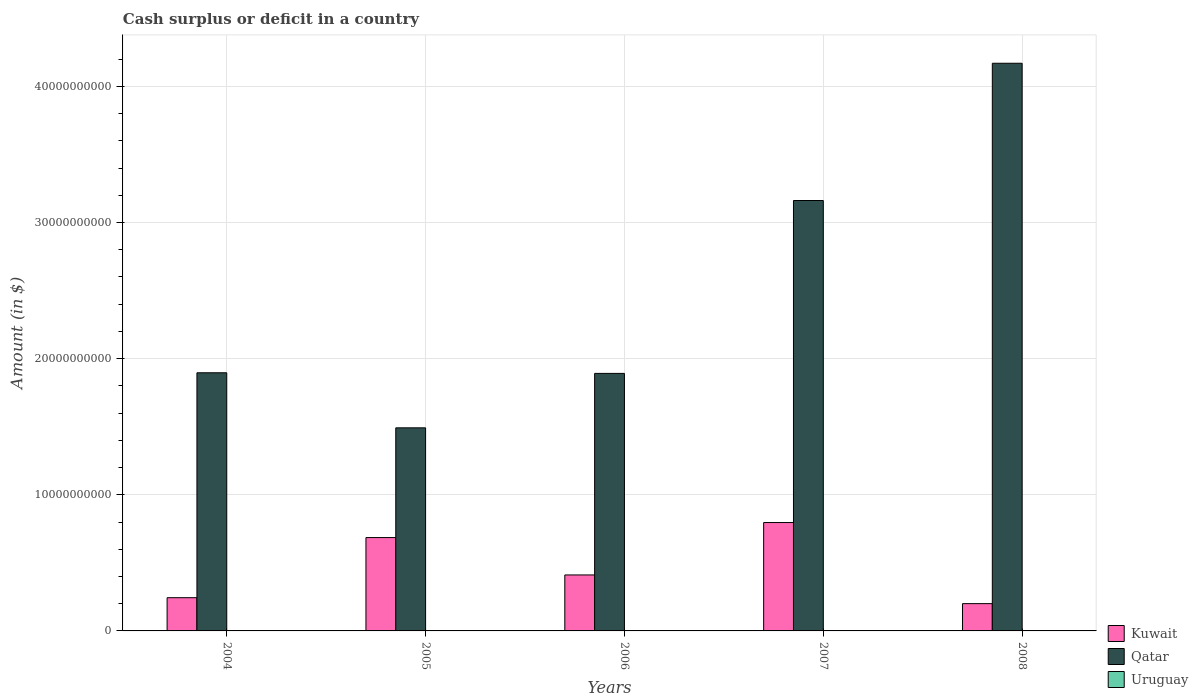How many groups of bars are there?
Ensure brevity in your answer.  5. How many bars are there on the 1st tick from the left?
Your answer should be very brief. 2. In how many cases, is the number of bars for a given year not equal to the number of legend labels?
Keep it short and to the point. 5. What is the amount of cash surplus or deficit in Qatar in 2004?
Provide a succinct answer. 1.90e+1. Across all years, what is the maximum amount of cash surplus or deficit in Kuwait?
Provide a short and direct response. 7.96e+09. Across all years, what is the minimum amount of cash surplus or deficit in Kuwait?
Give a very brief answer. 2.00e+09. What is the total amount of cash surplus or deficit in Qatar in the graph?
Keep it short and to the point. 1.26e+11. What is the difference between the amount of cash surplus or deficit in Qatar in 2005 and that in 2007?
Provide a short and direct response. -1.67e+1. What is the difference between the amount of cash surplus or deficit in Qatar in 2005 and the amount of cash surplus or deficit in Uruguay in 2006?
Your response must be concise. 1.49e+1. In the year 2006, what is the difference between the amount of cash surplus or deficit in Qatar and amount of cash surplus or deficit in Kuwait?
Ensure brevity in your answer.  1.48e+1. In how many years, is the amount of cash surplus or deficit in Qatar greater than 18000000000 $?
Provide a short and direct response. 4. What is the ratio of the amount of cash surplus or deficit in Kuwait in 2004 to that in 2007?
Keep it short and to the point. 0.31. Is the difference between the amount of cash surplus or deficit in Qatar in 2004 and 2008 greater than the difference between the amount of cash surplus or deficit in Kuwait in 2004 and 2008?
Make the answer very short. No. What is the difference between the highest and the second highest amount of cash surplus or deficit in Qatar?
Your response must be concise. 1.01e+1. What is the difference between the highest and the lowest amount of cash surplus or deficit in Kuwait?
Provide a succinct answer. 5.96e+09. In how many years, is the amount of cash surplus or deficit in Kuwait greater than the average amount of cash surplus or deficit in Kuwait taken over all years?
Your answer should be very brief. 2. Is the sum of the amount of cash surplus or deficit in Kuwait in 2005 and 2006 greater than the maximum amount of cash surplus or deficit in Qatar across all years?
Your answer should be very brief. No. How many bars are there?
Your answer should be compact. 10. Are all the bars in the graph horizontal?
Provide a succinct answer. No. Does the graph contain any zero values?
Keep it short and to the point. Yes. How many legend labels are there?
Your answer should be compact. 3. What is the title of the graph?
Provide a short and direct response. Cash surplus or deficit in a country. What is the label or title of the Y-axis?
Your response must be concise. Amount (in $). What is the Amount (in $) of Kuwait in 2004?
Offer a very short reply. 2.44e+09. What is the Amount (in $) of Qatar in 2004?
Provide a short and direct response. 1.90e+1. What is the Amount (in $) in Kuwait in 2005?
Provide a short and direct response. 6.86e+09. What is the Amount (in $) of Qatar in 2005?
Make the answer very short. 1.49e+1. What is the Amount (in $) of Uruguay in 2005?
Make the answer very short. 0. What is the Amount (in $) in Kuwait in 2006?
Provide a short and direct response. 4.11e+09. What is the Amount (in $) in Qatar in 2006?
Offer a very short reply. 1.89e+1. What is the Amount (in $) in Kuwait in 2007?
Ensure brevity in your answer.  7.96e+09. What is the Amount (in $) in Qatar in 2007?
Your answer should be very brief. 3.16e+1. What is the Amount (in $) of Uruguay in 2007?
Give a very brief answer. 0. What is the Amount (in $) in Kuwait in 2008?
Your answer should be compact. 2.00e+09. What is the Amount (in $) of Qatar in 2008?
Provide a short and direct response. 4.17e+1. What is the Amount (in $) of Uruguay in 2008?
Ensure brevity in your answer.  0. Across all years, what is the maximum Amount (in $) in Kuwait?
Your answer should be compact. 7.96e+09. Across all years, what is the maximum Amount (in $) in Qatar?
Your answer should be very brief. 4.17e+1. Across all years, what is the minimum Amount (in $) of Kuwait?
Ensure brevity in your answer.  2.00e+09. Across all years, what is the minimum Amount (in $) of Qatar?
Make the answer very short. 1.49e+1. What is the total Amount (in $) in Kuwait in the graph?
Offer a terse response. 2.34e+1. What is the total Amount (in $) of Qatar in the graph?
Your response must be concise. 1.26e+11. What is the total Amount (in $) of Uruguay in the graph?
Make the answer very short. 0. What is the difference between the Amount (in $) of Kuwait in 2004 and that in 2005?
Keep it short and to the point. -4.42e+09. What is the difference between the Amount (in $) in Qatar in 2004 and that in 2005?
Keep it short and to the point. 4.04e+09. What is the difference between the Amount (in $) of Kuwait in 2004 and that in 2006?
Your answer should be very brief. -1.67e+09. What is the difference between the Amount (in $) of Qatar in 2004 and that in 2006?
Your answer should be very brief. 4.60e+07. What is the difference between the Amount (in $) in Kuwait in 2004 and that in 2007?
Your answer should be very brief. -5.52e+09. What is the difference between the Amount (in $) in Qatar in 2004 and that in 2007?
Your answer should be compact. -1.27e+1. What is the difference between the Amount (in $) in Kuwait in 2004 and that in 2008?
Your answer should be very brief. 4.36e+08. What is the difference between the Amount (in $) of Qatar in 2004 and that in 2008?
Offer a very short reply. -2.27e+1. What is the difference between the Amount (in $) in Kuwait in 2005 and that in 2006?
Offer a terse response. 2.74e+09. What is the difference between the Amount (in $) of Qatar in 2005 and that in 2006?
Your answer should be compact. -4.00e+09. What is the difference between the Amount (in $) in Kuwait in 2005 and that in 2007?
Provide a short and direct response. -1.10e+09. What is the difference between the Amount (in $) in Qatar in 2005 and that in 2007?
Keep it short and to the point. -1.67e+1. What is the difference between the Amount (in $) of Kuwait in 2005 and that in 2008?
Your answer should be compact. 4.85e+09. What is the difference between the Amount (in $) in Qatar in 2005 and that in 2008?
Provide a short and direct response. -2.68e+1. What is the difference between the Amount (in $) of Kuwait in 2006 and that in 2007?
Your answer should be very brief. -3.85e+09. What is the difference between the Amount (in $) in Qatar in 2006 and that in 2007?
Your answer should be compact. -1.27e+1. What is the difference between the Amount (in $) of Kuwait in 2006 and that in 2008?
Offer a terse response. 2.11e+09. What is the difference between the Amount (in $) of Qatar in 2006 and that in 2008?
Provide a short and direct response. -2.28e+1. What is the difference between the Amount (in $) in Kuwait in 2007 and that in 2008?
Keep it short and to the point. 5.96e+09. What is the difference between the Amount (in $) in Qatar in 2007 and that in 2008?
Give a very brief answer. -1.01e+1. What is the difference between the Amount (in $) in Kuwait in 2004 and the Amount (in $) in Qatar in 2005?
Keep it short and to the point. -1.25e+1. What is the difference between the Amount (in $) of Kuwait in 2004 and the Amount (in $) of Qatar in 2006?
Your response must be concise. -1.65e+1. What is the difference between the Amount (in $) of Kuwait in 2004 and the Amount (in $) of Qatar in 2007?
Provide a succinct answer. -2.92e+1. What is the difference between the Amount (in $) of Kuwait in 2004 and the Amount (in $) of Qatar in 2008?
Make the answer very short. -3.93e+1. What is the difference between the Amount (in $) in Kuwait in 2005 and the Amount (in $) in Qatar in 2006?
Provide a short and direct response. -1.21e+1. What is the difference between the Amount (in $) of Kuwait in 2005 and the Amount (in $) of Qatar in 2007?
Provide a short and direct response. -2.48e+1. What is the difference between the Amount (in $) in Kuwait in 2005 and the Amount (in $) in Qatar in 2008?
Your answer should be very brief. -3.48e+1. What is the difference between the Amount (in $) in Kuwait in 2006 and the Amount (in $) in Qatar in 2007?
Your response must be concise. -2.75e+1. What is the difference between the Amount (in $) of Kuwait in 2006 and the Amount (in $) of Qatar in 2008?
Your response must be concise. -3.76e+1. What is the difference between the Amount (in $) of Kuwait in 2007 and the Amount (in $) of Qatar in 2008?
Provide a succinct answer. -3.37e+1. What is the average Amount (in $) in Kuwait per year?
Ensure brevity in your answer.  4.68e+09. What is the average Amount (in $) in Qatar per year?
Make the answer very short. 2.52e+1. In the year 2004, what is the difference between the Amount (in $) of Kuwait and Amount (in $) of Qatar?
Your answer should be compact. -1.65e+1. In the year 2005, what is the difference between the Amount (in $) of Kuwait and Amount (in $) of Qatar?
Your answer should be compact. -8.06e+09. In the year 2006, what is the difference between the Amount (in $) of Kuwait and Amount (in $) of Qatar?
Your answer should be compact. -1.48e+1. In the year 2007, what is the difference between the Amount (in $) in Kuwait and Amount (in $) in Qatar?
Ensure brevity in your answer.  -2.37e+1. In the year 2008, what is the difference between the Amount (in $) in Kuwait and Amount (in $) in Qatar?
Your response must be concise. -3.97e+1. What is the ratio of the Amount (in $) in Kuwait in 2004 to that in 2005?
Ensure brevity in your answer.  0.36. What is the ratio of the Amount (in $) in Qatar in 2004 to that in 2005?
Give a very brief answer. 1.27. What is the ratio of the Amount (in $) of Kuwait in 2004 to that in 2006?
Provide a short and direct response. 0.59. What is the ratio of the Amount (in $) of Qatar in 2004 to that in 2006?
Offer a very short reply. 1. What is the ratio of the Amount (in $) in Kuwait in 2004 to that in 2007?
Make the answer very short. 0.31. What is the ratio of the Amount (in $) of Qatar in 2004 to that in 2007?
Your answer should be compact. 0.6. What is the ratio of the Amount (in $) of Kuwait in 2004 to that in 2008?
Offer a very short reply. 1.22. What is the ratio of the Amount (in $) in Qatar in 2004 to that in 2008?
Your answer should be very brief. 0.45. What is the ratio of the Amount (in $) in Kuwait in 2005 to that in 2006?
Give a very brief answer. 1.67. What is the ratio of the Amount (in $) in Qatar in 2005 to that in 2006?
Provide a succinct answer. 0.79. What is the ratio of the Amount (in $) of Kuwait in 2005 to that in 2007?
Offer a terse response. 0.86. What is the ratio of the Amount (in $) of Qatar in 2005 to that in 2007?
Offer a terse response. 0.47. What is the ratio of the Amount (in $) of Kuwait in 2005 to that in 2008?
Give a very brief answer. 3.42. What is the ratio of the Amount (in $) of Qatar in 2005 to that in 2008?
Make the answer very short. 0.36. What is the ratio of the Amount (in $) of Kuwait in 2006 to that in 2007?
Give a very brief answer. 0.52. What is the ratio of the Amount (in $) in Qatar in 2006 to that in 2007?
Keep it short and to the point. 0.6. What is the ratio of the Amount (in $) in Kuwait in 2006 to that in 2008?
Ensure brevity in your answer.  2.05. What is the ratio of the Amount (in $) of Qatar in 2006 to that in 2008?
Keep it short and to the point. 0.45. What is the ratio of the Amount (in $) in Kuwait in 2007 to that in 2008?
Provide a short and direct response. 3.97. What is the ratio of the Amount (in $) in Qatar in 2007 to that in 2008?
Offer a very short reply. 0.76. What is the difference between the highest and the second highest Amount (in $) of Kuwait?
Keep it short and to the point. 1.10e+09. What is the difference between the highest and the second highest Amount (in $) in Qatar?
Give a very brief answer. 1.01e+1. What is the difference between the highest and the lowest Amount (in $) of Kuwait?
Give a very brief answer. 5.96e+09. What is the difference between the highest and the lowest Amount (in $) of Qatar?
Make the answer very short. 2.68e+1. 